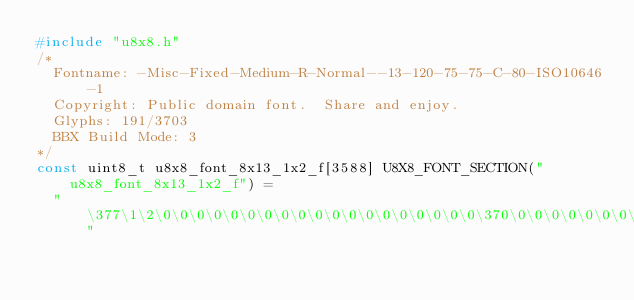Convert code to text. <code><loc_0><loc_0><loc_500><loc_500><_C_>#include "u8x8.h"
/*
  Fontname: -Misc-Fixed-Medium-R-Normal--13-120-75-75-C-80-ISO10646-1
  Copyright: Public domain font.  Share and enjoy.
  Glyphs: 191/3703
  BBX Build Mode: 3
*/
const uint8_t u8x8_font_8x13_1x2_f[3588] U8X8_FONT_SECTION("u8x8_font_8x13_1x2_f") = 
  " \377\1\2\0\0\0\0\0\0\0\0\0\0\0\0\0\0\0\0\0\0\0\370\0\0\0\0\0\0\0\13"</code> 